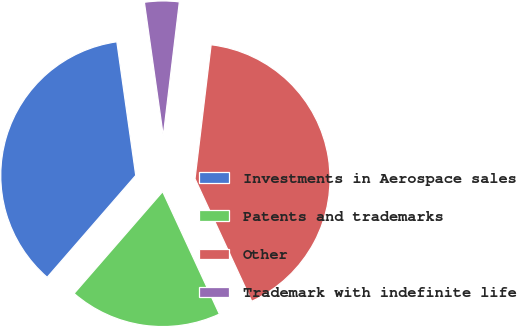<chart> <loc_0><loc_0><loc_500><loc_500><pie_chart><fcel>Investments in Aerospace sales<fcel>Patents and trademarks<fcel>Other<fcel>Trademark with indefinite life<nl><fcel>36.37%<fcel>18.29%<fcel>41.19%<fcel>4.14%<nl></chart> 